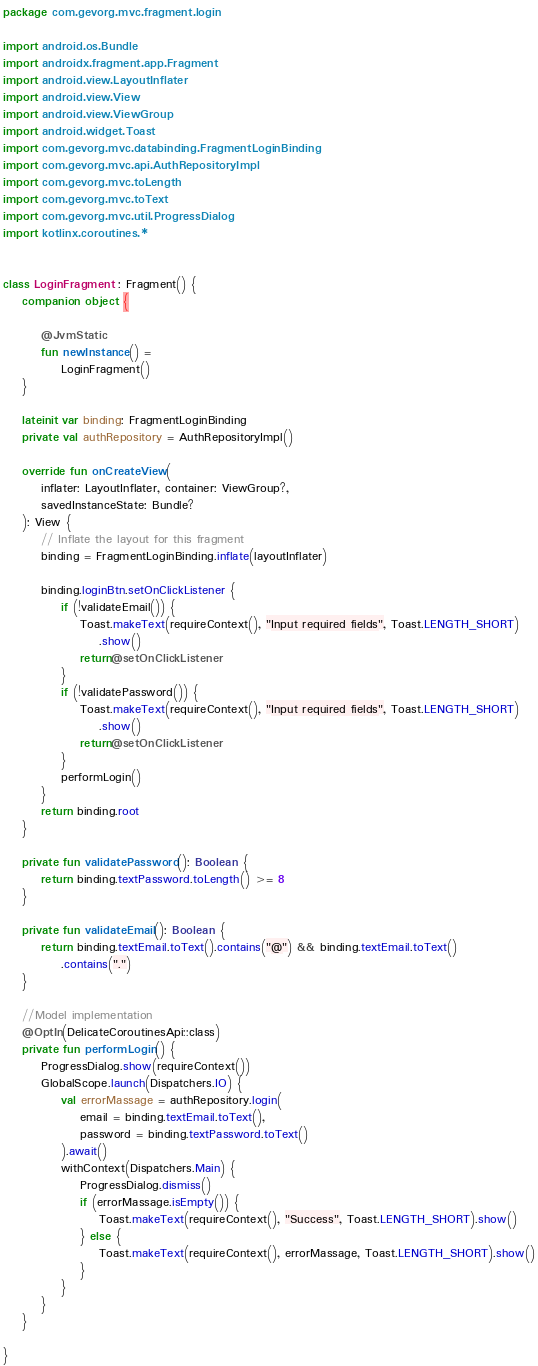Convert code to text. <code><loc_0><loc_0><loc_500><loc_500><_Kotlin_>package com.gevorg.mvc.fragment.login

import android.os.Bundle
import androidx.fragment.app.Fragment
import android.view.LayoutInflater
import android.view.View
import android.view.ViewGroup
import android.widget.Toast
import com.gevorg.mvc.databinding.FragmentLoginBinding
import com.gevorg.mvc.api.AuthRepositoryImpl
import com.gevorg.mvc.toLength
import com.gevorg.mvc.toText
import com.gevorg.mvc.util.ProgressDialog
import kotlinx.coroutines.*


class LoginFragment : Fragment() {
    companion object {

        @JvmStatic
        fun newInstance() =
            LoginFragment()
    }

    lateinit var binding: FragmentLoginBinding
    private val authRepository = AuthRepositoryImpl()

    override fun onCreateView(
        inflater: LayoutInflater, container: ViewGroup?,
        savedInstanceState: Bundle?
    ): View {
        // Inflate the layout for this fragment
        binding = FragmentLoginBinding.inflate(layoutInflater)

        binding.loginBtn.setOnClickListener {
            if (!validateEmail()) {
                Toast.makeText(requireContext(), "Input required fields", Toast.LENGTH_SHORT)
                    .show()
                return@setOnClickListener
            }
            if (!validatePassword()) {
                Toast.makeText(requireContext(), "Input required fields", Toast.LENGTH_SHORT)
                    .show()
                return@setOnClickListener
            }
            performLogin()
        }
        return binding.root
    }

    private fun validatePassword(): Boolean {
        return binding.textPassword.toLength() >= 8
    }

    private fun validateEmail(): Boolean {
        return binding.textEmail.toText().contains("@") && binding.textEmail.toText()
            .contains(".")
    }

    //Model implementation
    @OptIn(DelicateCoroutinesApi::class)
    private fun performLogin() {
        ProgressDialog.show(requireContext())
        GlobalScope.launch(Dispatchers.IO) {
            val errorMassage = authRepository.login(
                email = binding.textEmail.toText(),
                password = binding.textPassword.toText()
            ).await()
            withContext(Dispatchers.Main) {
                ProgressDialog.dismiss()
                if (errorMassage.isEmpty()) {
                    Toast.makeText(requireContext(), "Success", Toast.LENGTH_SHORT).show()
                } else {
                    Toast.makeText(requireContext(), errorMassage, Toast.LENGTH_SHORT).show()
                }
            }
        }
    }

}</code> 